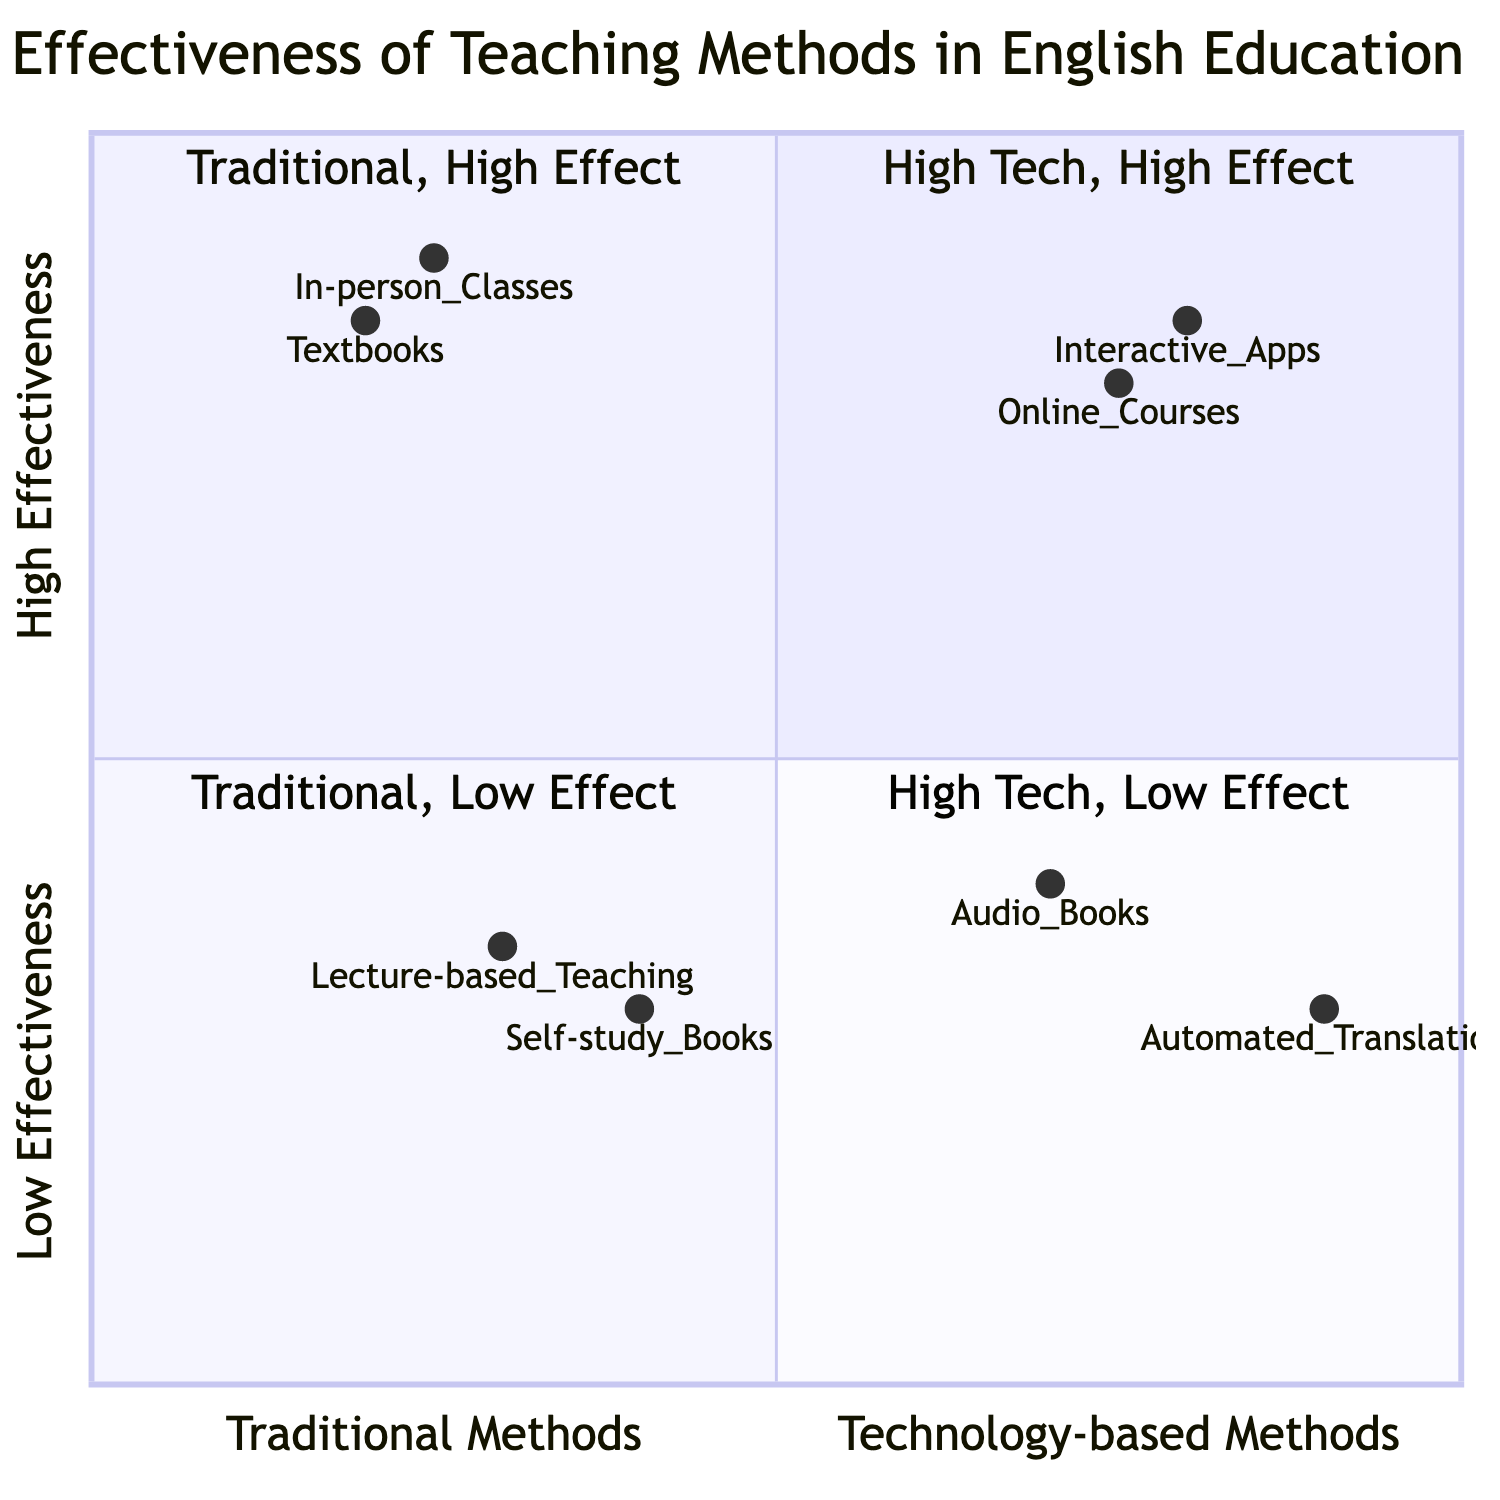What methods are categorized in the High Tech, High Effectiveness quadrant? In the diagram, the first quadrant (High Tech, High Effectiveness) contains "Interactive Apps" and "Online Courses," both of which are methods that utilize technology effectively.
Answer: Interactive Apps, Online Courses Which traditional method shows the highest effectiveness? By analyzing the quadrant associated with traditional methods, "In-person Classes" is positioned highest in effectiveness, indicating that it is very effective compared to other traditional methods.
Answer: In-person Classes What is the effectiveness value of Automated Translation Tools? The position of "Automated Translation Tools" in the low effectiveness quadrant indicates a value of 0.9 on the x-axis (for technology-based) and 0.3 on the y-axis (for low effectiveness).
Answer: 0.3 How many methods are categorized in the Low Effectiveness quadrant? The low effectiveness quadrant contains three methods: "Automated Translation Tools," "Audio Books," and "Self-study Books." Thus, the total number of methods in this quadrant is three.
Answer: 3 Which method has a higher effectiveness: Online Courses or Textbooks? The effectiveness value of "Online Courses" is 0.75, while the effectiveness of "Textbooks" is 0.85. Since 0.85 is greater than 0.75, "Textbooks" are more effective than "Online Courses."
Answer: Textbooks What is located in the Traditional, Low Effectiveness quadrant? The Traditional, Low Effectiveness quadrant includes two methods: "Lecture-based Teaching" and "Self-study Books," indicating that these methods are less effective in traditional education.
Answer: Lecture-based Teaching, Self-study Books Which method is the least effective based on the diagram? The method with the lowest effectiveness in the diagram is "Self-study Books," which is positioned in the Traditional, Low Effectiveness quadrant with an effectiveness value of 0.3.
Answer: Self-study Books What is the effectiveness value of Interactive Apps? For "Interactive Apps," the effectiveness value is represented by the coordinates [0.8, 0.85], indicating that it has a high effectiveness of 0.85 on the y-axis.
Answer: 0.85 Where do Online Courses fall in the quadrant chart? "Online Courses" fall in the High Tech, High Effectiveness quadrant, as its coordinates [0.75, 0.8] show it in the high effectiveness region with technology-based methods.
Answer: High Tech, High Effectiveness quadrant 